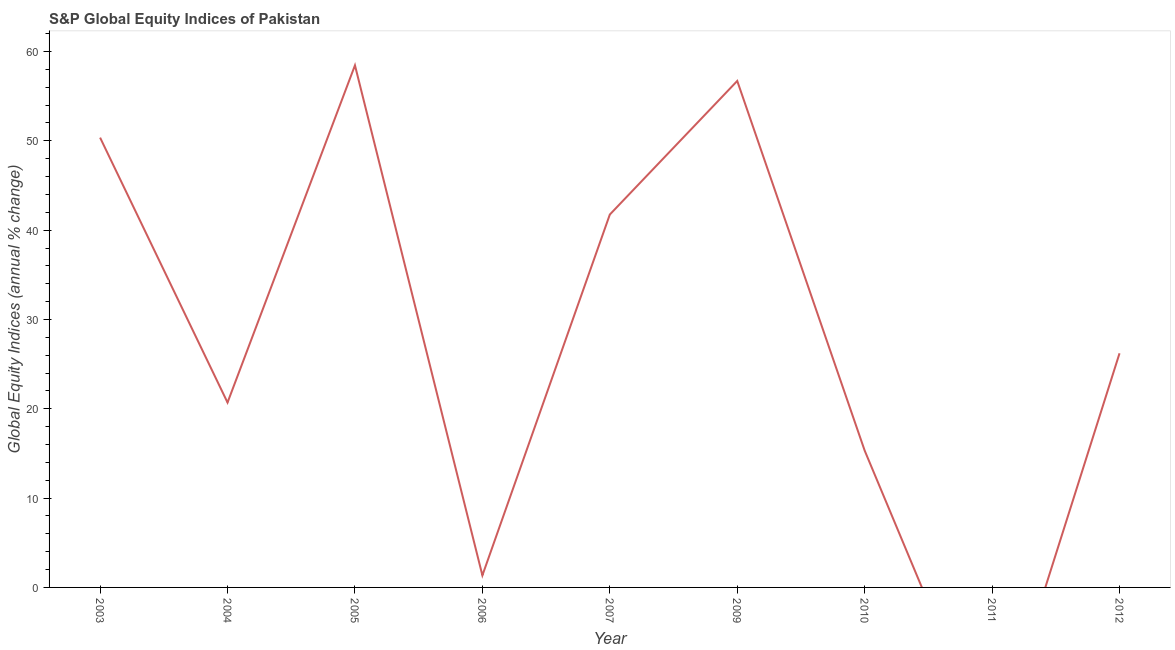What is the s&p global equity indices in 2009?
Give a very brief answer. 56.71. Across all years, what is the maximum s&p global equity indices?
Keep it short and to the point. 58.45. In which year was the s&p global equity indices maximum?
Provide a short and direct response. 2005. What is the sum of the s&p global equity indices?
Ensure brevity in your answer.  270.85. What is the difference between the s&p global equity indices in 2005 and 2010?
Provide a succinct answer. 43.13. What is the average s&p global equity indices per year?
Your answer should be compact. 30.09. What is the median s&p global equity indices?
Your answer should be compact. 26.21. What is the ratio of the s&p global equity indices in 2005 to that in 2009?
Keep it short and to the point. 1.03. Is the s&p global equity indices in 2004 less than that in 2007?
Ensure brevity in your answer.  Yes. Is the difference between the s&p global equity indices in 2006 and 2012 greater than the difference between any two years?
Your answer should be very brief. No. What is the difference between the highest and the second highest s&p global equity indices?
Your answer should be compact. 1.75. Is the sum of the s&p global equity indices in 2003 and 2005 greater than the maximum s&p global equity indices across all years?
Provide a short and direct response. Yes. What is the difference between the highest and the lowest s&p global equity indices?
Provide a succinct answer. 58.45. In how many years, is the s&p global equity indices greater than the average s&p global equity indices taken over all years?
Make the answer very short. 4. Does the s&p global equity indices monotonically increase over the years?
Ensure brevity in your answer.  No. How many lines are there?
Ensure brevity in your answer.  1. What is the difference between two consecutive major ticks on the Y-axis?
Give a very brief answer. 10. Does the graph contain any zero values?
Make the answer very short. Yes. What is the title of the graph?
Make the answer very short. S&P Global Equity Indices of Pakistan. What is the label or title of the Y-axis?
Your answer should be very brief. Global Equity Indices (annual % change). What is the Global Equity Indices (annual % change) of 2003?
Give a very brief answer. 50.36. What is the Global Equity Indices (annual % change) in 2004?
Offer a very short reply. 20.7. What is the Global Equity Indices (annual % change) of 2005?
Make the answer very short. 58.45. What is the Global Equity Indices (annual % change) of 2006?
Offer a terse response. 1.35. What is the Global Equity Indices (annual % change) in 2007?
Offer a very short reply. 41.75. What is the Global Equity Indices (annual % change) in 2009?
Your answer should be compact. 56.71. What is the Global Equity Indices (annual % change) of 2010?
Offer a very short reply. 15.32. What is the Global Equity Indices (annual % change) in 2012?
Your response must be concise. 26.21. What is the difference between the Global Equity Indices (annual % change) in 2003 and 2004?
Provide a short and direct response. 29.66. What is the difference between the Global Equity Indices (annual % change) in 2003 and 2005?
Give a very brief answer. -8.09. What is the difference between the Global Equity Indices (annual % change) in 2003 and 2006?
Offer a terse response. 49.01. What is the difference between the Global Equity Indices (annual % change) in 2003 and 2007?
Make the answer very short. 8.61. What is the difference between the Global Equity Indices (annual % change) in 2003 and 2009?
Keep it short and to the point. -6.35. What is the difference between the Global Equity Indices (annual % change) in 2003 and 2010?
Your answer should be compact. 35.04. What is the difference between the Global Equity Indices (annual % change) in 2003 and 2012?
Offer a terse response. 24.15. What is the difference between the Global Equity Indices (annual % change) in 2004 and 2005?
Make the answer very short. -37.75. What is the difference between the Global Equity Indices (annual % change) in 2004 and 2006?
Make the answer very short. 19.35. What is the difference between the Global Equity Indices (annual % change) in 2004 and 2007?
Offer a very short reply. -21.05. What is the difference between the Global Equity Indices (annual % change) in 2004 and 2009?
Ensure brevity in your answer.  -36.01. What is the difference between the Global Equity Indices (annual % change) in 2004 and 2010?
Your answer should be very brief. 5.38. What is the difference between the Global Equity Indices (annual % change) in 2004 and 2012?
Make the answer very short. -5.51. What is the difference between the Global Equity Indices (annual % change) in 2005 and 2006?
Give a very brief answer. 57.11. What is the difference between the Global Equity Indices (annual % change) in 2005 and 2007?
Offer a very short reply. 16.71. What is the difference between the Global Equity Indices (annual % change) in 2005 and 2009?
Your answer should be very brief. 1.75. What is the difference between the Global Equity Indices (annual % change) in 2005 and 2010?
Your answer should be compact. 43.13. What is the difference between the Global Equity Indices (annual % change) in 2005 and 2012?
Give a very brief answer. 32.24. What is the difference between the Global Equity Indices (annual % change) in 2006 and 2007?
Provide a short and direct response. -40.4. What is the difference between the Global Equity Indices (annual % change) in 2006 and 2009?
Your answer should be compact. -55.36. What is the difference between the Global Equity Indices (annual % change) in 2006 and 2010?
Make the answer very short. -13.97. What is the difference between the Global Equity Indices (annual % change) in 2006 and 2012?
Your answer should be very brief. -24.87. What is the difference between the Global Equity Indices (annual % change) in 2007 and 2009?
Ensure brevity in your answer.  -14.96. What is the difference between the Global Equity Indices (annual % change) in 2007 and 2010?
Ensure brevity in your answer.  26.43. What is the difference between the Global Equity Indices (annual % change) in 2007 and 2012?
Your answer should be very brief. 15.53. What is the difference between the Global Equity Indices (annual % change) in 2009 and 2010?
Provide a succinct answer. 41.39. What is the difference between the Global Equity Indices (annual % change) in 2009 and 2012?
Your answer should be compact. 30.49. What is the difference between the Global Equity Indices (annual % change) in 2010 and 2012?
Offer a terse response. -10.89. What is the ratio of the Global Equity Indices (annual % change) in 2003 to that in 2004?
Your answer should be compact. 2.43. What is the ratio of the Global Equity Indices (annual % change) in 2003 to that in 2005?
Give a very brief answer. 0.86. What is the ratio of the Global Equity Indices (annual % change) in 2003 to that in 2006?
Give a very brief answer. 37.4. What is the ratio of the Global Equity Indices (annual % change) in 2003 to that in 2007?
Your answer should be compact. 1.21. What is the ratio of the Global Equity Indices (annual % change) in 2003 to that in 2009?
Your answer should be very brief. 0.89. What is the ratio of the Global Equity Indices (annual % change) in 2003 to that in 2010?
Offer a terse response. 3.29. What is the ratio of the Global Equity Indices (annual % change) in 2003 to that in 2012?
Provide a short and direct response. 1.92. What is the ratio of the Global Equity Indices (annual % change) in 2004 to that in 2005?
Provide a short and direct response. 0.35. What is the ratio of the Global Equity Indices (annual % change) in 2004 to that in 2006?
Offer a very short reply. 15.37. What is the ratio of the Global Equity Indices (annual % change) in 2004 to that in 2007?
Provide a succinct answer. 0.5. What is the ratio of the Global Equity Indices (annual % change) in 2004 to that in 2009?
Provide a short and direct response. 0.36. What is the ratio of the Global Equity Indices (annual % change) in 2004 to that in 2010?
Your answer should be compact. 1.35. What is the ratio of the Global Equity Indices (annual % change) in 2004 to that in 2012?
Make the answer very short. 0.79. What is the ratio of the Global Equity Indices (annual % change) in 2005 to that in 2006?
Provide a short and direct response. 43.41. What is the ratio of the Global Equity Indices (annual % change) in 2005 to that in 2007?
Provide a short and direct response. 1.4. What is the ratio of the Global Equity Indices (annual % change) in 2005 to that in 2009?
Provide a succinct answer. 1.03. What is the ratio of the Global Equity Indices (annual % change) in 2005 to that in 2010?
Offer a very short reply. 3.81. What is the ratio of the Global Equity Indices (annual % change) in 2005 to that in 2012?
Give a very brief answer. 2.23. What is the ratio of the Global Equity Indices (annual % change) in 2006 to that in 2007?
Keep it short and to the point. 0.03. What is the ratio of the Global Equity Indices (annual % change) in 2006 to that in 2009?
Your response must be concise. 0.02. What is the ratio of the Global Equity Indices (annual % change) in 2006 to that in 2010?
Your response must be concise. 0.09. What is the ratio of the Global Equity Indices (annual % change) in 2006 to that in 2012?
Make the answer very short. 0.05. What is the ratio of the Global Equity Indices (annual % change) in 2007 to that in 2009?
Offer a very short reply. 0.74. What is the ratio of the Global Equity Indices (annual % change) in 2007 to that in 2010?
Make the answer very short. 2.73. What is the ratio of the Global Equity Indices (annual % change) in 2007 to that in 2012?
Offer a terse response. 1.59. What is the ratio of the Global Equity Indices (annual % change) in 2009 to that in 2010?
Provide a succinct answer. 3.7. What is the ratio of the Global Equity Indices (annual % change) in 2009 to that in 2012?
Your answer should be compact. 2.16. What is the ratio of the Global Equity Indices (annual % change) in 2010 to that in 2012?
Ensure brevity in your answer.  0.58. 